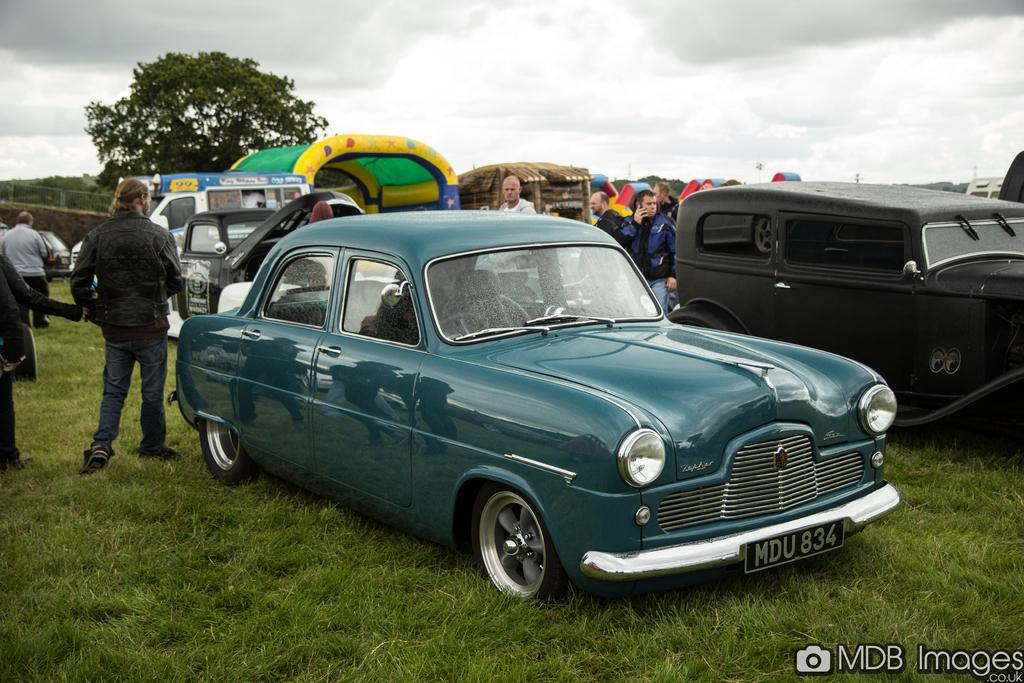<image>
Give a short and clear explanation of the subsequent image. a license plate on a car that says MDU on it 